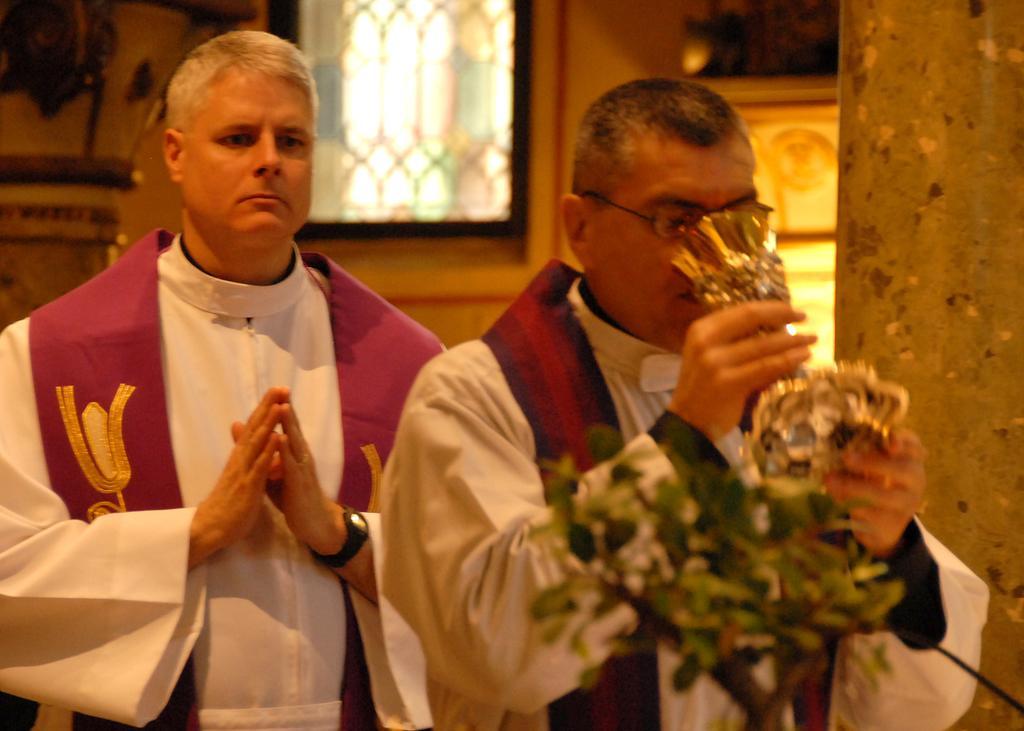In one or two sentences, can you explain what this image depicts? In this image we can see two men standing. In that a man is holding a glass. We can also see a plant, wall and a window. 